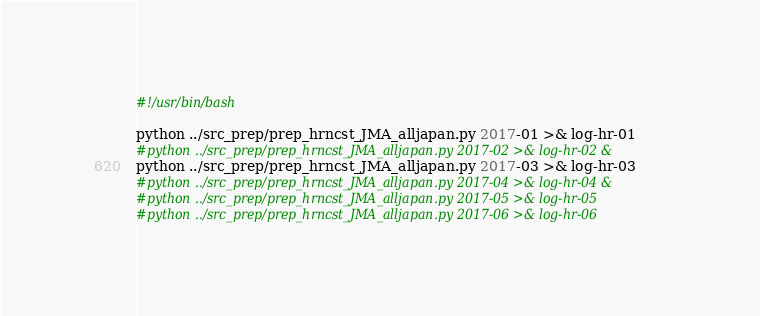Convert code to text. <code><loc_0><loc_0><loc_500><loc_500><_Bash_>#!/usr/bin/bash

python ../src_prep/prep_hrncst_JMA_alljapan.py 2017-01 >& log-hr-01 
#python ../src_prep/prep_hrncst_JMA_alljapan.py 2017-02 >& log-hr-02 &
python ../src_prep/prep_hrncst_JMA_alljapan.py 2017-03 >& log-hr-03
#python ../src_prep/prep_hrncst_JMA_alljapan.py 2017-04 >& log-hr-04 &
#python ../src_prep/prep_hrncst_JMA_alljapan.py 2017-05 >& log-hr-05
#python ../src_prep/prep_hrncst_JMA_alljapan.py 2017-06 >& log-hr-06

</code> 